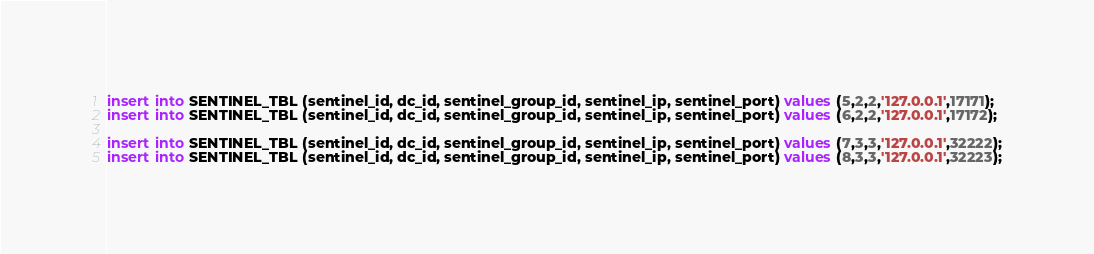Convert code to text. <code><loc_0><loc_0><loc_500><loc_500><_SQL_>insert into SENTINEL_TBL (sentinel_id, dc_id, sentinel_group_id, sentinel_ip, sentinel_port) values (5,2,2,'127.0.0.1',17171);
insert into SENTINEL_TBL (sentinel_id, dc_id, sentinel_group_id, sentinel_ip, sentinel_port) values (6,2,2,'127.0.0.1',17172);

insert into SENTINEL_TBL (sentinel_id, dc_id, sentinel_group_id, sentinel_ip, sentinel_port) values (7,3,3,'127.0.0.1',32222);
insert into SENTINEL_TBL (sentinel_id, dc_id, sentinel_group_id, sentinel_ip, sentinel_port) values (8,3,3,'127.0.0.1',32223);



</code> 